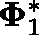<formula> <loc_0><loc_0><loc_500><loc_500>\Phi _ { 1 } ^ { * }</formula> 